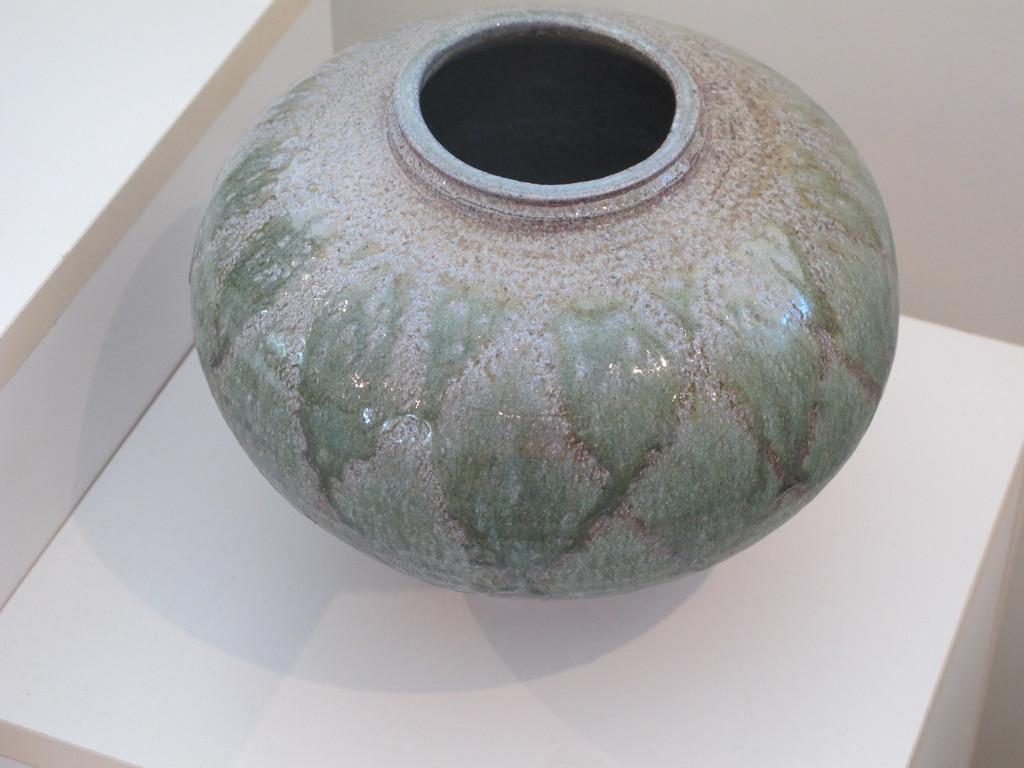Describe this image in one or two sentences. In this picture I can observe a porcelain pot placed on the white color desk. In the background there is a wall. 